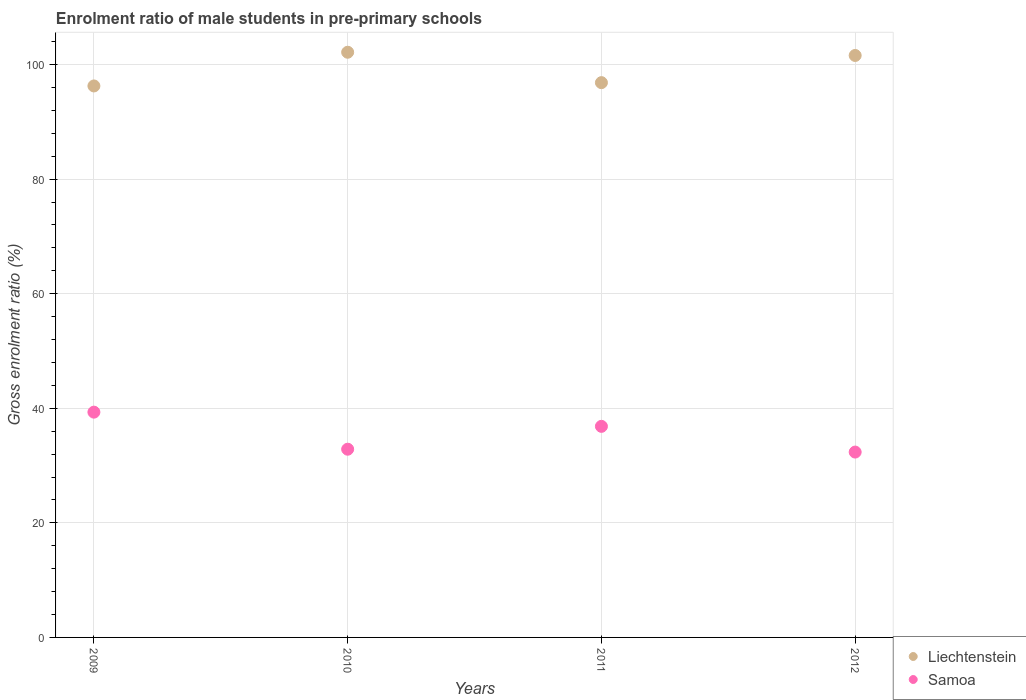What is the enrolment ratio of male students in pre-primary schools in Liechtenstein in 2012?
Provide a succinct answer. 101.59. Across all years, what is the maximum enrolment ratio of male students in pre-primary schools in Samoa?
Your response must be concise. 39.33. Across all years, what is the minimum enrolment ratio of male students in pre-primary schools in Samoa?
Keep it short and to the point. 32.36. In which year was the enrolment ratio of male students in pre-primary schools in Samoa minimum?
Give a very brief answer. 2012. What is the total enrolment ratio of male students in pre-primary schools in Liechtenstein in the graph?
Your answer should be compact. 396.85. What is the difference between the enrolment ratio of male students in pre-primary schools in Liechtenstein in 2009 and that in 2011?
Your answer should be compact. -0.58. What is the difference between the enrolment ratio of male students in pre-primary schools in Liechtenstein in 2011 and the enrolment ratio of male students in pre-primary schools in Samoa in 2009?
Provide a succinct answer. 57.52. What is the average enrolment ratio of male students in pre-primary schools in Liechtenstein per year?
Offer a terse response. 99.21. In the year 2009, what is the difference between the enrolment ratio of male students in pre-primary schools in Liechtenstein and enrolment ratio of male students in pre-primary schools in Samoa?
Your answer should be compact. 56.94. What is the ratio of the enrolment ratio of male students in pre-primary schools in Samoa in 2010 to that in 2012?
Offer a terse response. 1.02. Is the enrolment ratio of male students in pre-primary schools in Samoa in 2009 less than that in 2011?
Offer a terse response. No. What is the difference between the highest and the second highest enrolment ratio of male students in pre-primary schools in Samoa?
Give a very brief answer. 2.48. What is the difference between the highest and the lowest enrolment ratio of male students in pre-primary schools in Liechtenstein?
Offer a very short reply. 5.88. In how many years, is the enrolment ratio of male students in pre-primary schools in Liechtenstein greater than the average enrolment ratio of male students in pre-primary schools in Liechtenstein taken over all years?
Your answer should be very brief. 2. Is the sum of the enrolment ratio of male students in pre-primary schools in Liechtenstein in 2009 and 2011 greater than the maximum enrolment ratio of male students in pre-primary schools in Samoa across all years?
Offer a very short reply. Yes. Is the enrolment ratio of male students in pre-primary schools in Liechtenstein strictly greater than the enrolment ratio of male students in pre-primary schools in Samoa over the years?
Ensure brevity in your answer.  Yes. Is the enrolment ratio of male students in pre-primary schools in Samoa strictly less than the enrolment ratio of male students in pre-primary schools in Liechtenstein over the years?
Ensure brevity in your answer.  Yes. How many dotlines are there?
Your answer should be very brief. 2. How many years are there in the graph?
Provide a short and direct response. 4. What is the difference between two consecutive major ticks on the Y-axis?
Give a very brief answer. 20. What is the title of the graph?
Your response must be concise. Enrolment ratio of male students in pre-primary schools. Does "Guinea" appear as one of the legend labels in the graph?
Ensure brevity in your answer.  No. What is the label or title of the X-axis?
Keep it short and to the point. Years. What is the Gross enrolment ratio (%) in Liechtenstein in 2009?
Give a very brief answer. 96.27. What is the Gross enrolment ratio (%) of Samoa in 2009?
Offer a terse response. 39.33. What is the Gross enrolment ratio (%) in Liechtenstein in 2010?
Your answer should be compact. 102.15. What is the Gross enrolment ratio (%) in Samoa in 2010?
Offer a terse response. 32.86. What is the Gross enrolment ratio (%) of Liechtenstein in 2011?
Offer a terse response. 96.84. What is the Gross enrolment ratio (%) in Samoa in 2011?
Keep it short and to the point. 36.85. What is the Gross enrolment ratio (%) of Liechtenstein in 2012?
Make the answer very short. 101.59. What is the Gross enrolment ratio (%) of Samoa in 2012?
Ensure brevity in your answer.  32.36. Across all years, what is the maximum Gross enrolment ratio (%) of Liechtenstein?
Give a very brief answer. 102.15. Across all years, what is the maximum Gross enrolment ratio (%) of Samoa?
Ensure brevity in your answer.  39.33. Across all years, what is the minimum Gross enrolment ratio (%) in Liechtenstein?
Provide a short and direct response. 96.27. Across all years, what is the minimum Gross enrolment ratio (%) in Samoa?
Offer a very short reply. 32.36. What is the total Gross enrolment ratio (%) in Liechtenstein in the graph?
Keep it short and to the point. 396.85. What is the total Gross enrolment ratio (%) in Samoa in the graph?
Your answer should be very brief. 141.38. What is the difference between the Gross enrolment ratio (%) in Liechtenstein in 2009 and that in 2010?
Make the answer very short. -5.88. What is the difference between the Gross enrolment ratio (%) in Samoa in 2009 and that in 2010?
Your response must be concise. 6.47. What is the difference between the Gross enrolment ratio (%) of Liechtenstein in 2009 and that in 2011?
Offer a very short reply. -0.58. What is the difference between the Gross enrolment ratio (%) in Samoa in 2009 and that in 2011?
Make the answer very short. 2.48. What is the difference between the Gross enrolment ratio (%) of Liechtenstein in 2009 and that in 2012?
Provide a short and direct response. -5.32. What is the difference between the Gross enrolment ratio (%) of Samoa in 2009 and that in 2012?
Your answer should be compact. 6.97. What is the difference between the Gross enrolment ratio (%) of Liechtenstein in 2010 and that in 2011?
Ensure brevity in your answer.  5.31. What is the difference between the Gross enrolment ratio (%) of Samoa in 2010 and that in 2011?
Your answer should be very brief. -3.99. What is the difference between the Gross enrolment ratio (%) of Liechtenstein in 2010 and that in 2012?
Offer a very short reply. 0.56. What is the difference between the Gross enrolment ratio (%) of Liechtenstein in 2011 and that in 2012?
Your answer should be very brief. -4.75. What is the difference between the Gross enrolment ratio (%) in Samoa in 2011 and that in 2012?
Ensure brevity in your answer.  4.49. What is the difference between the Gross enrolment ratio (%) of Liechtenstein in 2009 and the Gross enrolment ratio (%) of Samoa in 2010?
Keep it short and to the point. 63.41. What is the difference between the Gross enrolment ratio (%) of Liechtenstein in 2009 and the Gross enrolment ratio (%) of Samoa in 2011?
Ensure brevity in your answer.  59.42. What is the difference between the Gross enrolment ratio (%) in Liechtenstein in 2009 and the Gross enrolment ratio (%) in Samoa in 2012?
Ensure brevity in your answer.  63.91. What is the difference between the Gross enrolment ratio (%) in Liechtenstein in 2010 and the Gross enrolment ratio (%) in Samoa in 2011?
Offer a very short reply. 65.3. What is the difference between the Gross enrolment ratio (%) of Liechtenstein in 2010 and the Gross enrolment ratio (%) of Samoa in 2012?
Offer a very short reply. 69.79. What is the difference between the Gross enrolment ratio (%) of Liechtenstein in 2011 and the Gross enrolment ratio (%) of Samoa in 2012?
Provide a succinct answer. 64.49. What is the average Gross enrolment ratio (%) in Liechtenstein per year?
Keep it short and to the point. 99.21. What is the average Gross enrolment ratio (%) of Samoa per year?
Give a very brief answer. 35.35. In the year 2009, what is the difference between the Gross enrolment ratio (%) of Liechtenstein and Gross enrolment ratio (%) of Samoa?
Your response must be concise. 56.94. In the year 2010, what is the difference between the Gross enrolment ratio (%) of Liechtenstein and Gross enrolment ratio (%) of Samoa?
Provide a succinct answer. 69.29. In the year 2011, what is the difference between the Gross enrolment ratio (%) of Liechtenstein and Gross enrolment ratio (%) of Samoa?
Your response must be concise. 60. In the year 2012, what is the difference between the Gross enrolment ratio (%) in Liechtenstein and Gross enrolment ratio (%) in Samoa?
Ensure brevity in your answer.  69.23. What is the ratio of the Gross enrolment ratio (%) in Liechtenstein in 2009 to that in 2010?
Ensure brevity in your answer.  0.94. What is the ratio of the Gross enrolment ratio (%) in Samoa in 2009 to that in 2010?
Provide a short and direct response. 1.2. What is the ratio of the Gross enrolment ratio (%) in Liechtenstein in 2009 to that in 2011?
Offer a terse response. 0.99. What is the ratio of the Gross enrolment ratio (%) of Samoa in 2009 to that in 2011?
Offer a very short reply. 1.07. What is the ratio of the Gross enrolment ratio (%) in Liechtenstein in 2009 to that in 2012?
Your answer should be compact. 0.95. What is the ratio of the Gross enrolment ratio (%) in Samoa in 2009 to that in 2012?
Offer a very short reply. 1.22. What is the ratio of the Gross enrolment ratio (%) in Liechtenstein in 2010 to that in 2011?
Give a very brief answer. 1.05. What is the ratio of the Gross enrolment ratio (%) in Samoa in 2010 to that in 2011?
Your answer should be very brief. 0.89. What is the ratio of the Gross enrolment ratio (%) in Liechtenstein in 2010 to that in 2012?
Your answer should be very brief. 1.01. What is the ratio of the Gross enrolment ratio (%) of Samoa in 2010 to that in 2012?
Your answer should be very brief. 1.02. What is the ratio of the Gross enrolment ratio (%) in Liechtenstein in 2011 to that in 2012?
Give a very brief answer. 0.95. What is the ratio of the Gross enrolment ratio (%) of Samoa in 2011 to that in 2012?
Ensure brevity in your answer.  1.14. What is the difference between the highest and the second highest Gross enrolment ratio (%) in Liechtenstein?
Give a very brief answer. 0.56. What is the difference between the highest and the second highest Gross enrolment ratio (%) in Samoa?
Offer a very short reply. 2.48. What is the difference between the highest and the lowest Gross enrolment ratio (%) in Liechtenstein?
Offer a terse response. 5.88. What is the difference between the highest and the lowest Gross enrolment ratio (%) in Samoa?
Ensure brevity in your answer.  6.97. 